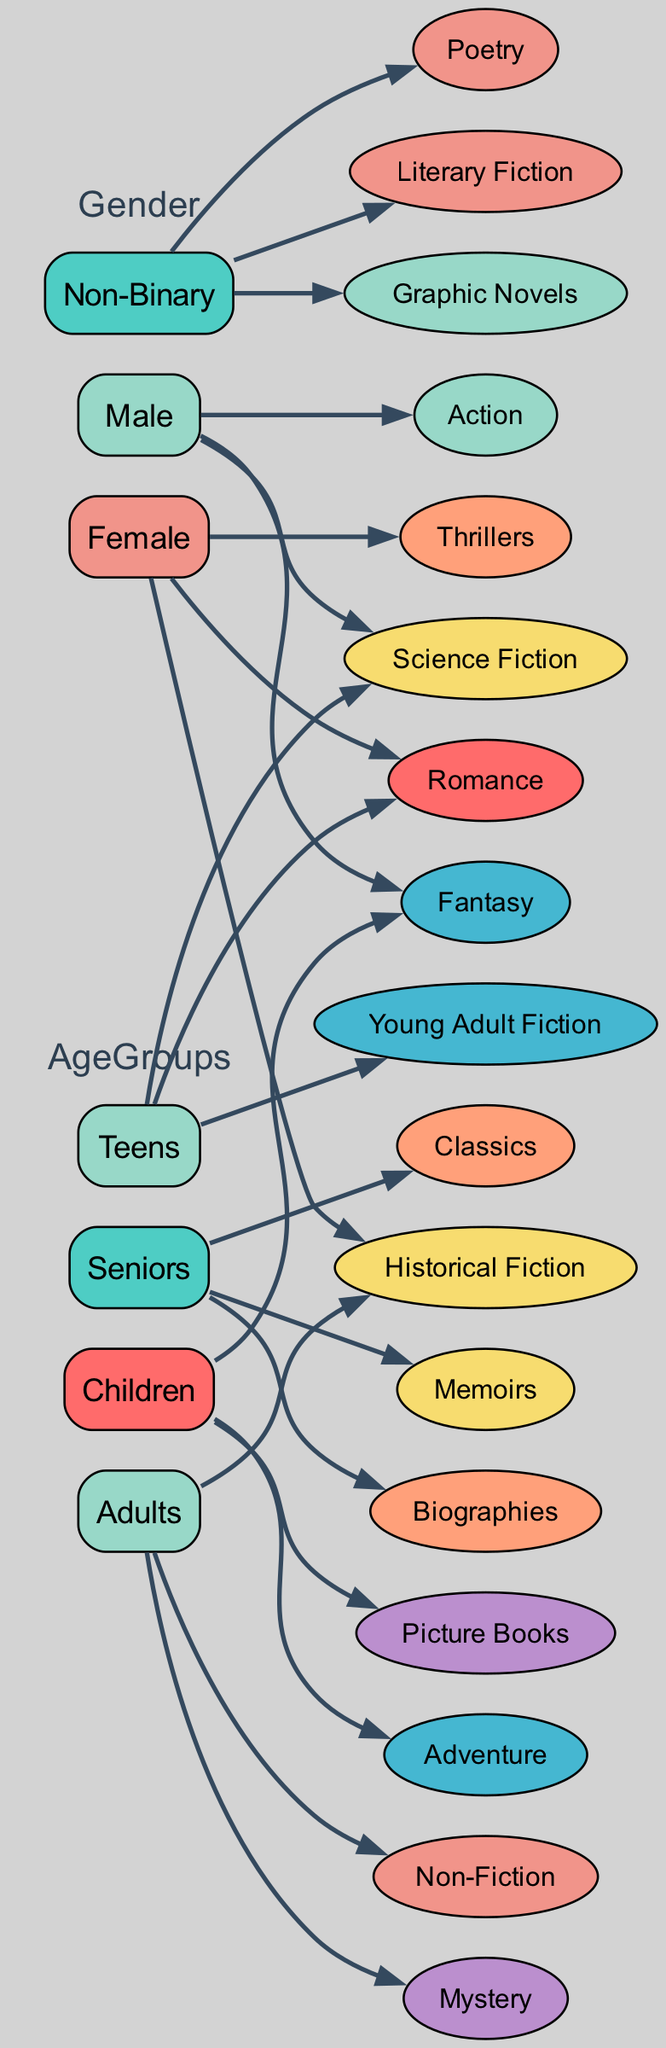What genres do children prefer? Children prefer the genres of Fantasy, Adventure, and Picture Books as indicated by their group in the diagram.
Answer: Fantasy, Adventure, Picture Books Which age group prefers Historical Fiction? The Adults group shows a preference for Historical Fiction according to the nodes connected to this genre.
Answer: Adults What is the total number of genres preferred by seniors? Seniors prefer three genres: Classics, Biographies, and Memoirs. By counting the connected genres, the total is three.
Answer: 3 Which gender prefers Science Fiction? The Male demographic is associated with the Science Fiction genre, as shown by the connections from the Male node to the Science Fiction genre node in the diagram.
Answer: Male What genre is preferred by Non-Binary readers? Non-Binary readers prefer Literary Fiction, Graphic Novels, and Poetry, as indicated by the edges leading from the Non-Binary node to these genres.
Answer: Literary Fiction, Graphic Novels, Poetry How many different age groups are represented in the diagram? There are four age groups represented: Children, Teens, Adults, and Seniors. The respective nodes under the AgeGroups category confirm this.
Answer: 4 Which genre is most commonly preferred by females? Females prefer Romance, Thrillers, and Historical Fiction. Romance is one of the genres preferred and highlighted the most in this demographic.
Answer: Romance How does the genre Adventure connect to the different reader demographics? Adventure is preferred by the Children group only and has an edge from the Children node to the Adventure genre node, showing its singular connection.
Answer: Children What relationship exists between Teens and Romance? Teens are connected to the Romance genre, indicating that this demographic shows a preference for this genre as indicated by the direction of the edges leading from the Teens node.
Answer: Preferred genre 